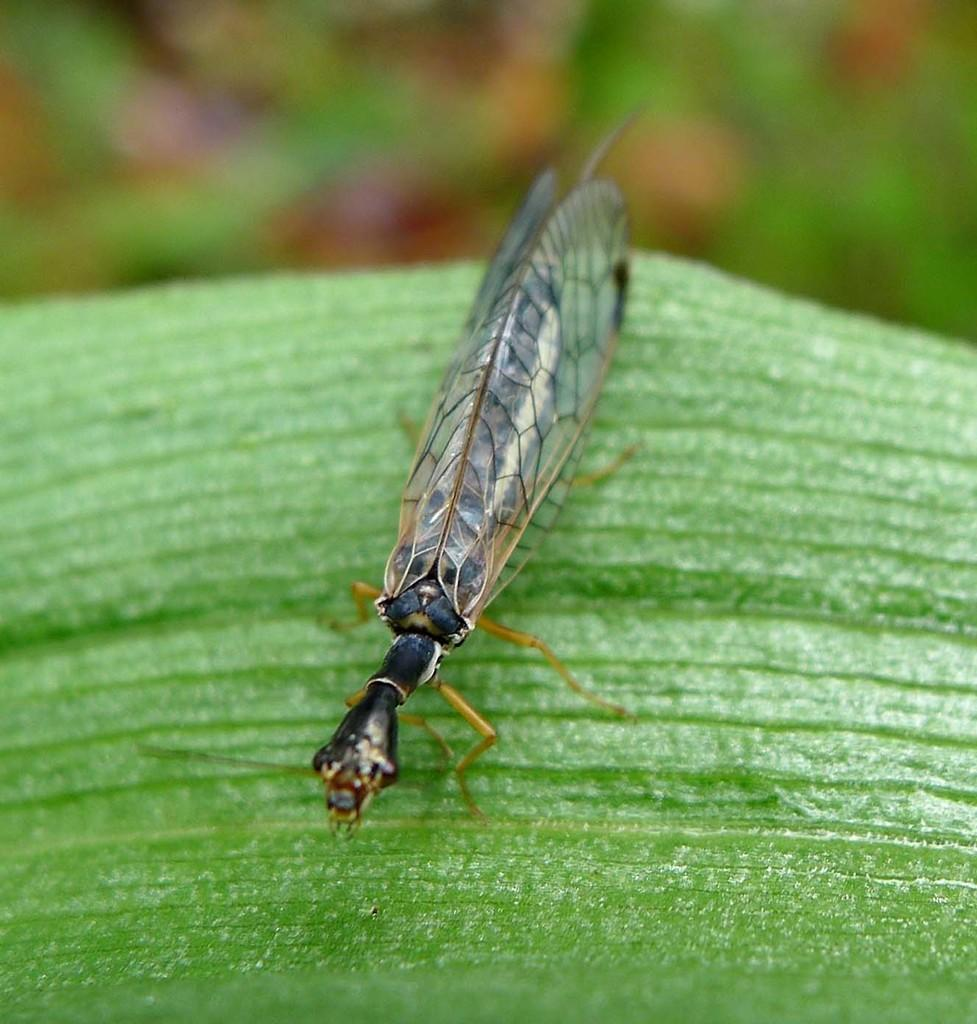What type of plant material is present in the image? There is a green leaf in the image. Is there any other living organism on the leaf? Yes, there is a black insect on the leaf. How would you describe the overall clarity of the image? The image is slightly blurry in the background. What type of music can be heard coming from the leaf in the image? There is no music present in the image, as it features a green leaf with a black insect on it. How many lizards are visible on the leaf in the image? There are no lizards present in the image; it only features a green leaf and a black insect. 